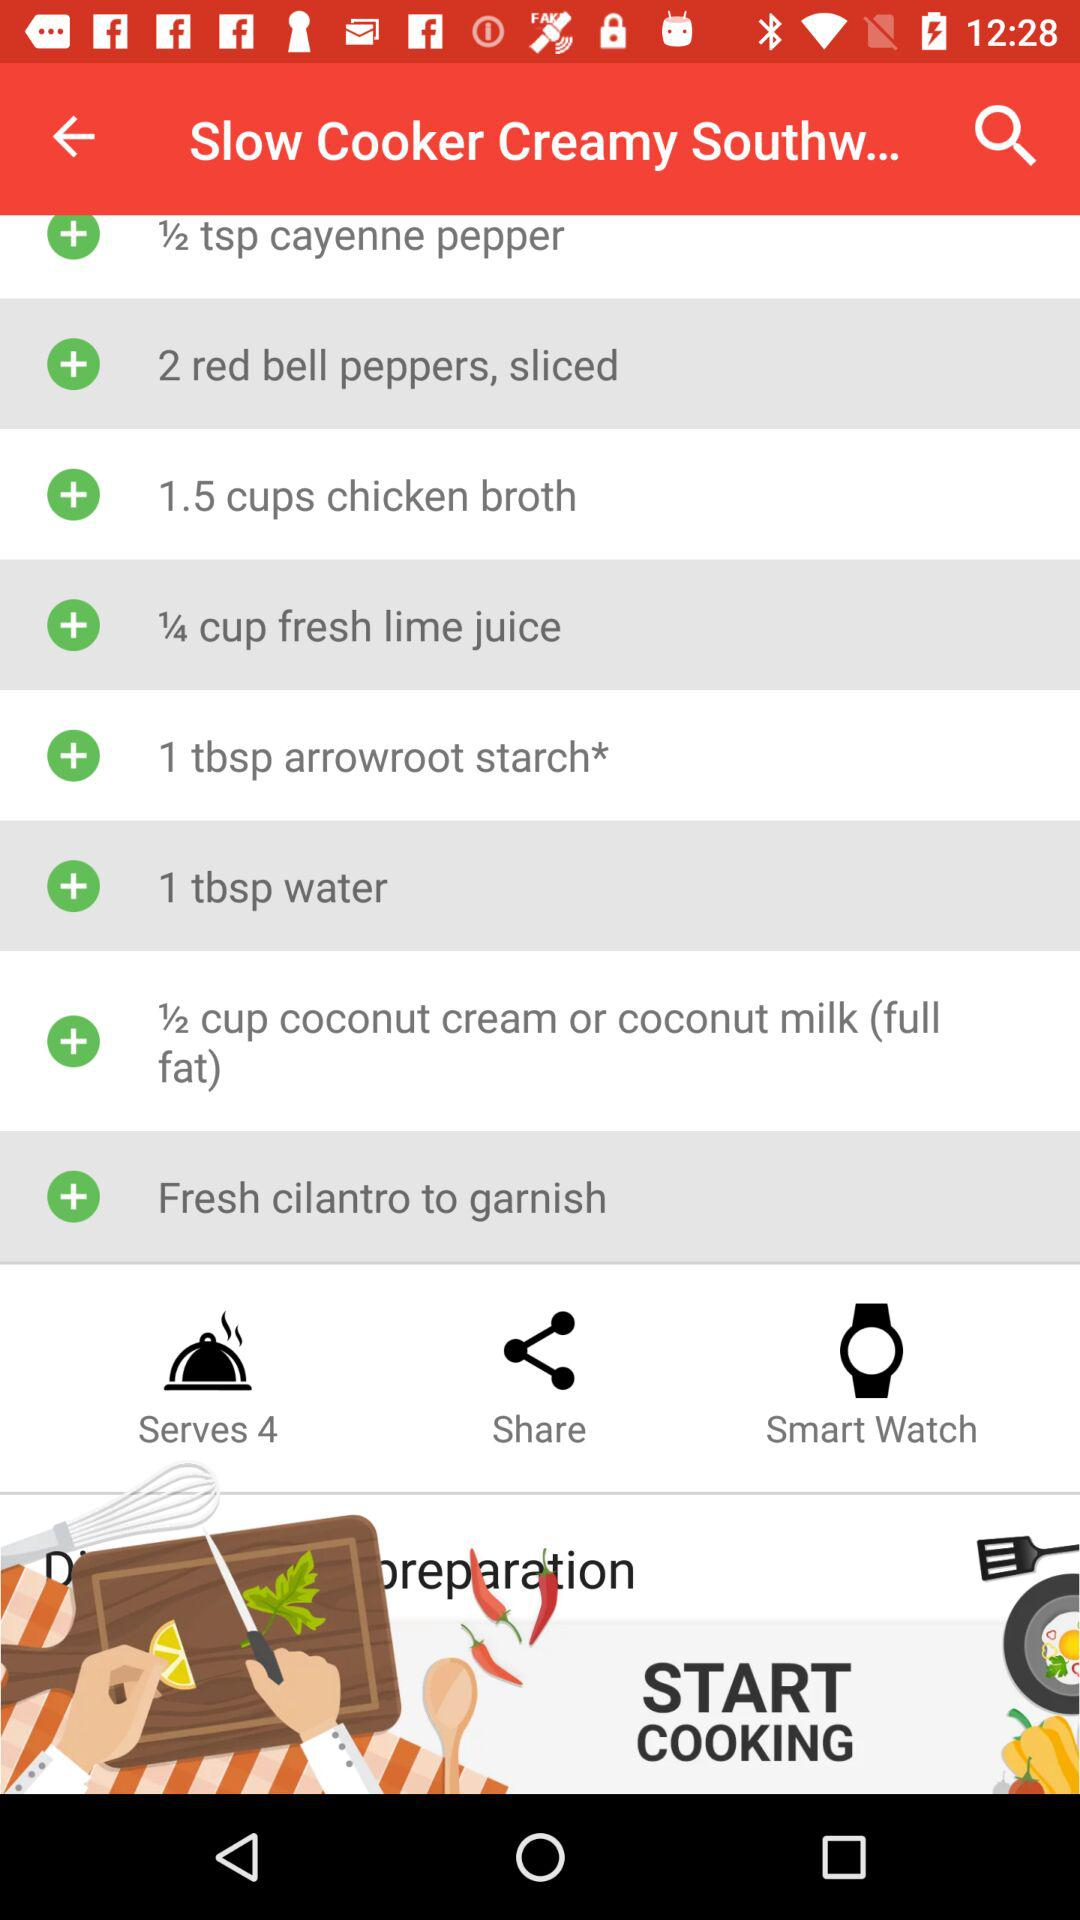How much coconut cream do we need to make the dish? You need 1/2 cup of coconut cream to make the dish. 